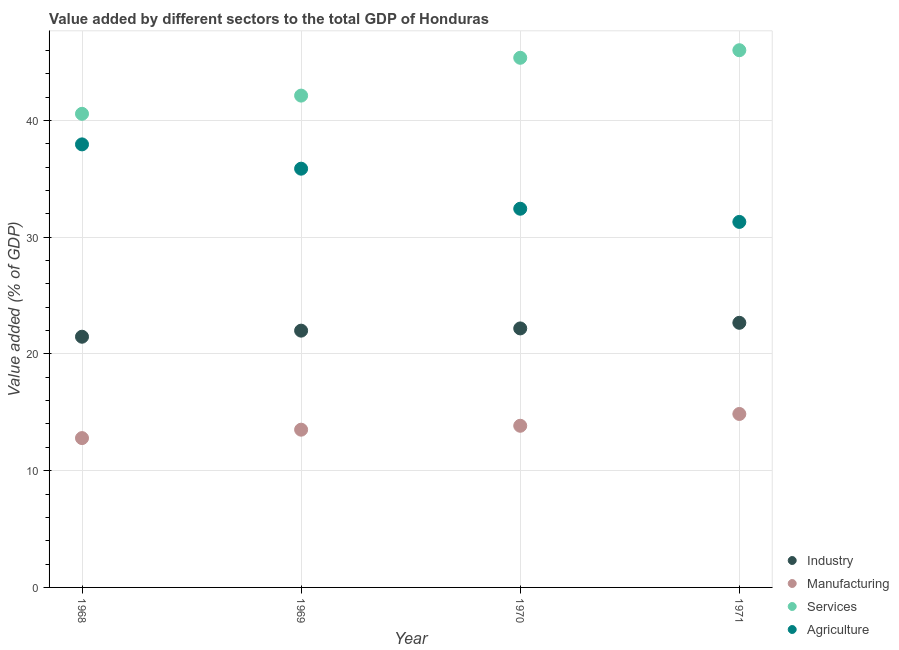How many different coloured dotlines are there?
Provide a short and direct response. 4. Is the number of dotlines equal to the number of legend labels?
Your answer should be very brief. Yes. What is the value added by services sector in 1969?
Offer a very short reply. 42.13. Across all years, what is the maximum value added by industrial sector?
Provide a short and direct response. 22.67. Across all years, what is the minimum value added by services sector?
Keep it short and to the point. 40.57. In which year was the value added by industrial sector maximum?
Offer a very short reply. 1971. In which year was the value added by services sector minimum?
Ensure brevity in your answer.  1968. What is the total value added by manufacturing sector in the graph?
Your answer should be very brief. 55.01. What is the difference between the value added by manufacturing sector in 1968 and that in 1969?
Keep it short and to the point. -0.72. What is the difference between the value added by industrial sector in 1969 and the value added by services sector in 1970?
Ensure brevity in your answer.  -23.37. What is the average value added by services sector per year?
Provide a short and direct response. 43.52. In the year 1971, what is the difference between the value added by industrial sector and value added by manufacturing sector?
Make the answer very short. 7.81. What is the ratio of the value added by agricultural sector in 1969 to that in 1970?
Make the answer very short. 1.11. Is the value added by services sector in 1969 less than that in 1971?
Offer a very short reply. Yes. Is the difference between the value added by agricultural sector in 1968 and 1970 greater than the difference between the value added by manufacturing sector in 1968 and 1970?
Offer a very short reply. Yes. What is the difference between the highest and the second highest value added by manufacturing sector?
Your answer should be compact. 1.01. What is the difference between the highest and the lowest value added by industrial sector?
Offer a terse response. 1.19. In how many years, is the value added by manufacturing sector greater than the average value added by manufacturing sector taken over all years?
Ensure brevity in your answer.  2. Is it the case that in every year, the sum of the value added by agricultural sector and value added by services sector is greater than the sum of value added by industrial sector and value added by manufacturing sector?
Ensure brevity in your answer.  Yes. Is the value added by manufacturing sector strictly less than the value added by agricultural sector over the years?
Provide a succinct answer. Yes. How many dotlines are there?
Keep it short and to the point. 4. What is the difference between two consecutive major ticks on the Y-axis?
Provide a succinct answer. 10. Are the values on the major ticks of Y-axis written in scientific E-notation?
Ensure brevity in your answer.  No. Does the graph contain any zero values?
Provide a succinct answer. No. Where does the legend appear in the graph?
Make the answer very short. Bottom right. How many legend labels are there?
Provide a short and direct response. 4. What is the title of the graph?
Your answer should be very brief. Value added by different sectors to the total GDP of Honduras. What is the label or title of the X-axis?
Keep it short and to the point. Year. What is the label or title of the Y-axis?
Ensure brevity in your answer.  Value added (% of GDP). What is the Value added (% of GDP) of Industry in 1968?
Your answer should be very brief. 21.48. What is the Value added (% of GDP) of Manufacturing in 1968?
Provide a short and direct response. 12.79. What is the Value added (% of GDP) of Services in 1968?
Offer a very short reply. 40.57. What is the Value added (% of GDP) of Agriculture in 1968?
Provide a short and direct response. 37.95. What is the Value added (% of GDP) of Industry in 1969?
Give a very brief answer. 22. What is the Value added (% of GDP) in Manufacturing in 1969?
Keep it short and to the point. 13.51. What is the Value added (% of GDP) in Services in 1969?
Your response must be concise. 42.13. What is the Value added (% of GDP) of Agriculture in 1969?
Offer a terse response. 35.87. What is the Value added (% of GDP) of Industry in 1970?
Make the answer very short. 22.19. What is the Value added (% of GDP) in Manufacturing in 1970?
Your answer should be very brief. 13.85. What is the Value added (% of GDP) in Services in 1970?
Make the answer very short. 45.37. What is the Value added (% of GDP) of Agriculture in 1970?
Your answer should be compact. 32.44. What is the Value added (% of GDP) of Industry in 1971?
Offer a very short reply. 22.67. What is the Value added (% of GDP) in Manufacturing in 1971?
Ensure brevity in your answer.  14.86. What is the Value added (% of GDP) in Services in 1971?
Give a very brief answer. 46.02. What is the Value added (% of GDP) in Agriculture in 1971?
Give a very brief answer. 31.31. Across all years, what is the maximum Value added (% of GDP) in Industry?
Provide a short and direct response. 22.67. Across all years, what is the maximum Value added (% of GDP) of Manufacturing?
Provide a succinct answer. 14.86. Across all years, what is the maximum Value added (% of GDP) in Services?
Provide a short and direct response. 46.02. Across all years, what is the maximum Value added (% of GDP) of Agriculture?
Give a very brief answer. 37.95. Across all years, what is the minimum Value added (% of GDP) in Industry?
Give a very brief answer. 21.48. Across all years, what is the minimum Value added (% of GDP) of Manufacturing?
Provide a short and direct response. 12.79. Across all years, what is the minimum Value added (% of GDP) in Services?
Make the answer very short. 40.57. Across all years, what is the minimum Value added (% of GDP) of Agriculture?
Give a very brief answer. 31.31. What is the total Value added (% of GDP) of Industry in the graph?
Keep it short and to the point. 88.33. What is the total Value added (% of GDP) in Manufacturing in the graph?
Make the answer very short. 55.01. What is the total Value added (% of GDP) of Services in the graph?
Keep it short and to the point. 174.09. What is the total Value added (% of GDP) in Agriculture in the graph?
Provide a succinct answer. 137.58. What is the difference between the Value added (% of GDP) of Industry in 1968 and that in 1969?
Your answer should be very brief. -0.52. What is the difference between the Value added (% of GDP) in Manufacturing in 1968 and that in 1969?
Offer a very short reply. -0.72. What is the difference between the Value added (% of GDP) in Services in 1968 and that in 1969?
Offer a terse response. -1.56. What is the difference between the Value added (% of GDP) of Agriculture in 1968 and that in 1969?
Provide a succinct answer. 2.08. What is the difference between the Value added (% of GDP) in Industry in 1968 and that in 1970?
Give a very brief answer. -0.71. What is the difference between the Value added (% of GDP) of Manufacturing in 1968 and that in 1970?
Offer a very short reply. -1.06. What is the difference between the Value added (% of GDP) in Services in 1968 and that in 1970?
Keep it short and to the point. -4.8. What is the difference between the Value added (% of GDP) of Agriculture in 1968 and that in 1970?
Offer a very short reply. 5.51. What is the difference between the Value added (% of GDP) of Industry in 1968 and that in 1971?
Ensure brevity in your answer.  -1.19. What is the difference between the Value added (% of GDP) of Manufacturing in 1968 and that in 1971?
Offer a very short reply. -2.07. What is the difference between the Value added (% of GDP) of Services in 1968 and that in 1971?
Offer a terse response. -5.45. What is the difference between the Value added (% of GDP) of Agriculture in 1968 and that in 1971?
Offer a very short reply. 6.64. What is the difference between the Value added (% of GDP) in Industry in 1969 and that in 1970?
Offer a very short reply. -0.19. What is the difference between the Value added (% of GDP) of Manufacturing in 1969 and that in 1970?
Make the answer very short. -0.34. What is the difference between the Value added (% of GDP) of Services in 1969 and that in 1970?
Your answer should be compact. -3.24. What is the difference between the Value added (% of GDP) of Agriculture in 1969 and that in 1970?
Keep it short and to the point. 3.43. What is the difference between the Value added (% of GDP) of Industry in 1969 and that in 1971?
Offer a very short reply. -0.67. What is the difference between the Value added (% of GDP) of Manufacturing in 1969 and that in 1971?
Give a very brief answer. -1.35. What is the difference between the Value added (% of GDP) in Services in 1969 and that in 1971?
Provide a succinct answer. -3.89. What is the difference between the Value added (% of GDP) of Agriculture in 1969 and that in 1971?
Give a very brief answer. 4.56. What is the difference between the Value added (% of GDP) of Industry in 1970 and that in 1971?
Make the answer very short. -0.48. What is the difference between the Value added (% of GDP) of Manufacturing in 1970 and that in 1971?
Keep it short and to the point. -1.01. What is the difference between the Value added (% of GDP) in Services in 1970 and that in 1971?
Keep it short and to the point. -0.65. What is the difference between the Value added (% of GDP) of Agriculture in 1970 and that in 1971?
Offer a very short reply. 1.13. What is the difference between the Value added (% of GDP) of Industry in 1968 and the Value added (% of GDP) of Manufacturing in 1969?
Offer a very short reply. 7.96. What is the difference between the Value added (% of GDP) in Industry in 1968 and the Value added (% of GDP) in Services in 1969?
Make the answer very short. -20.66. What is the difference between the Value added (% of GDP) of Industry in 1968 and the Value added (% of GDP) of Agriculture in 1969?
Your answer should be compact. -14.4. What is the difference between the Value added (% of GDP) of Manufacturing in 1968 and the Value added (% of GDP) of Services in 1969?
Make the answer very short. -29.34. What is the difference between the Value added (% of GDP) of Manufacturing in 1968 and the Value added (% of GDP) of Agriculture in 1969?
Ensure brevity in your answer.  -23.08. What is the difference between the Value added (% of GDP) in Services in 1968 and the Value added (% of GDP) in Agriculture in 1969?
Ensure brevity in your answer.  4.7. What is the difference between the Value added (% of GDP) in Industry in 1968 and the Value added (% of GDP) in Manufacturing in 1970?
Provide a succinct answer. 7.63. What is the difference between the Value added (% of GDP) of Industry in 1968 and the Value added (% of GDP) of Services in 1970?
Your answer should be compact. -23.9. What is the difference between the Value added (% of GDP) of Industry in 1968 and the Value added (% of GDP) of Agriculture in 1970?
Provide a succinct answer. -10.96. What is the difference between the Value added (% of GDP) in Manufacturing in 1968 and the Value added (% of GDP) in Services in 1970?
Provide a short and direct response. -32.58. What is the difference between the Value added (% of GDP) in Manufacturing in 1968 and the Value added (% of GDP) in Agriculture in 1970?
Your answer should be compact. -19.65. What is the difference between the Value added (% of GDP) of Services in 1968 and the Value added (% of GDP) of Agriculture in 1970?
Make the answer very short. 8.13. What is the difference between the Value added (% of GDP) in Industry in 1968 and the Value added (% of GDP) in Manufacturing in 1971?
Offer a terse response. 6.62. What is the difference between the Value added (% of GDP) in Industry in 1968 and the Value added (% of GDP) in Services in 1971?
Offer a terse response. -24.54. What is the difference between the Value added (% of GDP) of Industry in 1968 and the Value added (% of GDP) of Agriculture in 1971?
Your response must be concise. -9.84. What is the difference between the Value added (% of GDP) in Manufacturing in 1968 and the Value added (% of GDP) in Services in 1971?
Ensure brevity in your answer.  -33.23. What is the difference between the Value added (% of GDP) of Manufacturing in 1968 and the Value added (% of GDP) of Agriculture in 1971?
Provide a short and direct response. -18.52. What is the difference between the Value added (% of GDP) in Services in 1968 and the Value added (% of GDP) in Agriculture in 1971?
Your answer should be very brief. 9.26. What is the difference between the Value added (% of GDP) in Industry in 1969 and the Value added (% of GDP) in Manufacturing in 1970?
Your answer should be compact. 8.15. What is the difference between the Value added (% of GDP) in Industry in 1969 and the Value added (% of GDP) in Services in 1970?
Ensure brevity in your answer.  -23.37. What is the difference between the Value added (% of GDP) in Industry in 1969 and the Value added (% of GDP) in Agriculture in 1970?
Ensure brevity in your answer.  -10.44. What is the difference between the Value added (% of GDP) in Manufacturing in 1969 and the Value added (% of GDP) in Services in 1970?
Keep it short and to the point. -31.86. What is the difference between the Value added (% of GDP) in Manufacturing in 1969 and the Value added (% of GDP) in Agriculture in 1970?
Provide a short and direct response. -18.93. What is the difference between the Value added (% of GDP) in Services in 1969 and the Value added (% of GDP) in Agriculture in 1970?
Keep it short and to the point. 9.69. What is the difference between the Value added (% of GDP) in Industry in 1969 and the Value added (% of GDP) in Manufacturing in 1971?
Your answer should be very brief. 7.14. What is the difference between the Value added (% of GDP) of Industry in 1969 and the Value added (% of GDP) of Services in 1971?
Make the answer very short. -24.02. What is the difference between the Value added (% of GDP) in Industry in 1969 and the Value added (% of GDP) in Agriculture in 1971?
Your answer should be compact. -9.31. What is the difference between the Value added (% of GDP) of Manufacturing in 1969 and the Value added (% of GDP) of Services in 1971?
Give a very brief answer. -32.51. What is the difference between the Value added (% of GDP) in Manufacturing in 1969 and the Value added (% of GDP) in Agriculture in 1971?
Keep it short and to the point. -17.8. What is the difference between the Value added (% of GDP) in Services in 1969 and the Value added (% of GDP) in Agriculture in 1971?
Your answer should be very brief. 10.82. What is the difference between the Value added (% of GDP) in Industry in 1970 and the Value added (% of GDP) in Manufacturing in 1971?
Offer a terse response. 7.33. What is the difference between the Value added (% of GDP) of Industry in 1970 and the Value added (% of GDP) of Services in 1971?
Your response must be concise. -23.83. What is the difference between the Value added (% of GDP) in Industry in 1970 and the Value added (% of GDP) in Agriculture in 1971?
Offer a very short reply. -9.12. What is the difference between the Value added (% of GDP) of Manufacturing in 1970 and the Value added (% of GDP) of Services in 1971?
Offer a very short reply. -32.17. What is the difference between the Value added (% of GDP) in Manufacturing in 1970 and the Value added (% of GDP) in Agriculture in 1971?
Provide a succinct answer. -17.46. What is the difference between the Value added (% of GDP) of Services in 1970 and the Value added (% of GDP) of Agriculture in 1971?
Ensure brevity in your answer.  14.06. What is the average Value added (% of GDP) in Industry per year?
Provide a short and direct response. 22.08. What is the average Value added (% of GDP) in Manufacturing per year?
Offer a very short reply. 13.75. What is the average Value added (% of GDP) in Services per year?
Your answer should be compact. 43.52. What is the average Value added (% of GDP) in Agriculture per year?
Your answer should be very brief. 34.39. In the year 1968, what is the difference between the Value added (% of GDP) of Industry and Value added (% of GDP) of Manufacturing?
Offer a terse response. 8.68. In the year 1968, what is the difference between the Value added (% of GDP) in Industry and Value added (% of GDP) in Services?
Give a very brief answer. -19.1. In the year 1968, what is the difference between the Value added (% of GDP) in Industry and Value added (% of GDP) in Agriculture?
Keep it short and to the point. -16.48. In the year 1968, what is the difference between the Value added (% of GDP) in Manufacturing and Value added (% of GDP) in Services?
Provide a short and direct response. -27.78. In the year 1968, what is the difference between the Value added (% of GDP) in Manufacturing and Value added (% of GDP) in Agriculture?
Ensure brevity in your answer.  -25.16. In the year 1968, what is the difference between the Value added (% of GDP) of Services and Value added (% of GDP) of Agriculture?
Your response must be concise. 2.62. In the year 1969, what is the difference between the Value added (% of GDP) of Industry and Value added (% of GDP) of Manufacturing?
Your answer should be compact. 8.48. In the year 1969, what is the difference between the Value added (% of GDP) in Industry and Value added (% of GDP) in Services?
Provide a succinct answer. -20.13. In the year 1969, what is the difference between the Value added (% of GDP) in Industry and Value added (% of GDP) in Agriculture?
Make the answer very short. -13.87. In the year 1969, what is the difference between the Value added (% of GDP) in Manufacturing and Value added (% of GDP) in Services?
Provide a succinct answer. -28.62. In the year 1969, what is the difference between the Value added (% of GDP) of Manufacturing and Value added (% of GDP) of Agriculture?
Provide a short and direct response. -22.36. In the year 1969, what is the difference between the Value added (% of GDP) in Services and Value added (% of GDP) in Agriculture?
Your answer should be very brief. 6.26. In the year 1970, what is the difference between the Value added (% of GDP) in Industry and Value added (% of GDP) in Manufacturing?
Provide a succinct answer. 8.34. In the year 1970, what is the difference between the Value added (% of GDP) in Industry and Value added (% of GDP) in Services?
Give a very brief answer. -23.18. In the year 1970, what is the difference between the Value added (% of GDP) in Industry and Value added (% of GDP) in Agriculture?
Offer a terse response. -10.25. In the year 1970, what is the difference between the Value added (% of GDP) of Manufacturing and Value added (% of GDP) of Services?
Give a very brief answer. -31.52. In the year 1970, what is the difference between the Value added (% of GDP) of Manufacturing and Value added (% of GDP) of Agriculture?
Your answer should be very brief. -18.59. In the year 1970, what is the difference between the Value added (% of GDP) in Services and Value added (% of GDP) in Agriculture?
Provide a short and direct response. 12.93. In the year 1971, what is the difference between the Value added (% of GDP) of Industry and Value added (% of GDP) of Manufacturing?
Your response must be concise. 7.81. In the year 1971, what is the difference between the Value added (% of GDP) in Industry and Value added (% of GDP) in Services?
Offer a very short reply. -23.35. In the year 1971, what is the difference between the Value added (% of GDP) in Industry and Value added (% of GDP) in Agriculture?
Ensure brevity in your answer.  -8.64. In the year 1971, what is the difference between the Value added (% of GDP) of Manufacturing and Value added (% of GDP) of Services?
Your response must be concise. -31.16. In the year 1971, what is the difference between the Value added (% of GDP) in Manufacturing and Value added (% of GDP) in Agriculture?
Give a very brief answer. -16.45. In the year 1971, what is the difference between the Value added (% of GDP) in Services and Value added (% of GDP) in Agriculture?
Ensure brevity in your answer.  14.71. What is the ratio of the Value added (% of GDP) of Industry in 1968 to that in 1969?
Make the answer very short. 0.98. What is the ratio of the Value added (% of GDP) in Manufacturing in 1968 to that in 1969?
Provide a short and direct response. 0.95. What is the ratio of the Value added (% of GDP) of Agriculture in 1968 to that in 1969?
Provide a succinct answer. 1.06. What is the ratio of the Value added (% of GDP) of Industry in 1968 to that in 1970?
Provide a succinct answer. 0.97. What is the ratio of the Value added (% of GDP) in Manufacturing in 1968 to that in 1970?
Offer a very short reply. 0.92. What is the ratio of the Value added (% of GDP) in Services in 1968 to that in 1970?
Provide a succinct answer. 0.89. What is the ratio of the Value added (% of GDP) of Agriculture in 1968 to that in 1970?
Keep it short and to the point. 1.17. What is the ratio of the Value added (% of GDP) in Manufacturing in 1968 to that in 1971?
Offer a terse response. 0.86. What is the ratio of the Value added (% of GDP) of Services in 1968 to that in 1971?
Give a very brief answer. 0.88. What is the ratio of the Value added (% of GDP) in Agriculture in 1968 to that in 1971?
Ensure brevity in your answer.  1.21. What is the ratio of the Value added (% of GDP) in Industry in 1969 to that in 1970?
Offer a very short reply. 0.99. What is the ratio of the Value added (% of GDP) in Manufacturing in 1969 to that in 1970?
Your response must be concise. 0.98. What is the ratio of the Value added (% of GDP) of Services in 1969 to that in 1970?
Provide a succinct answer. 0.93. What is the ratio of the Value added (% of GDP) in Agriculture in 1969 to that in 1970?
Provide a short and direct response. 1.11. What is the ratio of the Value added (% of GDP) of Industry in 1969 to that in 1971?
Your answer should be compact. 0.97. What is the ratio of the Value added (% of GDP) in Manufacturing in 1969 to that in 1971?
Make the answer very short. 0.91. What is the ratio of the Value added (% of GDP) of Services in 1969 to that in 1971?
Offer a terse response. 0.92. What is the ratio of the Value added (% of GDP) of Agriculture in 1969 to that in 1971?
Keep it short and to the point. 1.15. What is the ratio of the Value added (% of GDP) of Industry in 1970 to that in 1971?
Your response must be concise. 0.98. What is the ratio of the Value added (% of GDP) in Manufacturing in 1970 to that in 1971?
Provide a short and direct response. 0.93. What is the ratio of the Value added (% of GDP) in Services in 1970 to that in 1971?
Your answer should be compact. 0.99. What is the ratio of the Value added (% of GDP) in Agriculture in 1970 to that in 1971?
Provide a short and direct response. 1.04. What is the difference between the highest and the second highest Value added (% of GDP) of Industry?
Provide a short and direct response. 0.48. What is the difference between the highest and the second highest Value added (% of GDP) in Manufacturing?
Offer a very short reply. 1.01. What is the difference between the highest and the second highest Value added (% of GDP) of Services?
Keep it short and to the point. 0.65. What is the difference between the highest and the second highest Value added (% of GDP) of Agriculture?
Make the answer very short. 2.08. What is the difference between the highest and the lowest Value added (% of GDP) of Industry?
Keep it short and to the point. 1.19. What is the difference between the highest and the lowest Value added (% of GDP) of Manufacturing?
Make the answer very short. 2.07. What is the difference between the highest and the lowest Value added (% of GDP) of Services?
Offer a very short reply. 5.45. What is the difference between the highest and the lowest Value added (% of GDP) in Agriculture?
Give a very brief answer. 6.64. 